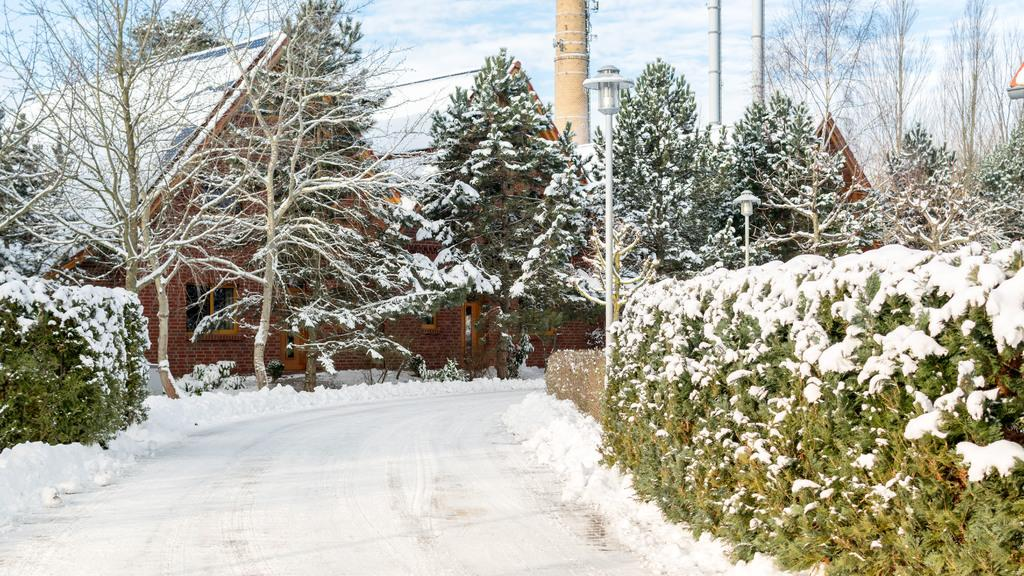What type of structures can be seen in the image? There are houses in the image. What other natural elements are present in the image? Trees and plants are visible in the image. How is the image characterized by the presence of snow? The houses, trees, and plants are covered with snow. What type of card is being used by the laborer in the image? There is no laborer or card present in the image. 